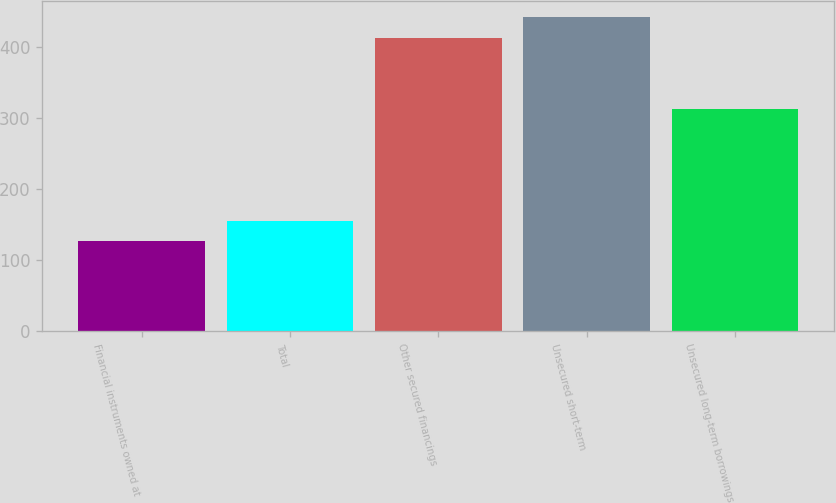Convert chart. <chart><loc_0><loc_0><loc_500><loc_500><bar_chart><fcel>Financial instruments owned at<fcel>Total<fcel>Other secured financings<fcel>Unsecured short-term<fcel>Unsecured long-term borrowings<nl><fcel>126<fcel>155<fcel>413<fcel>442<fcel>312<nl></chart> 